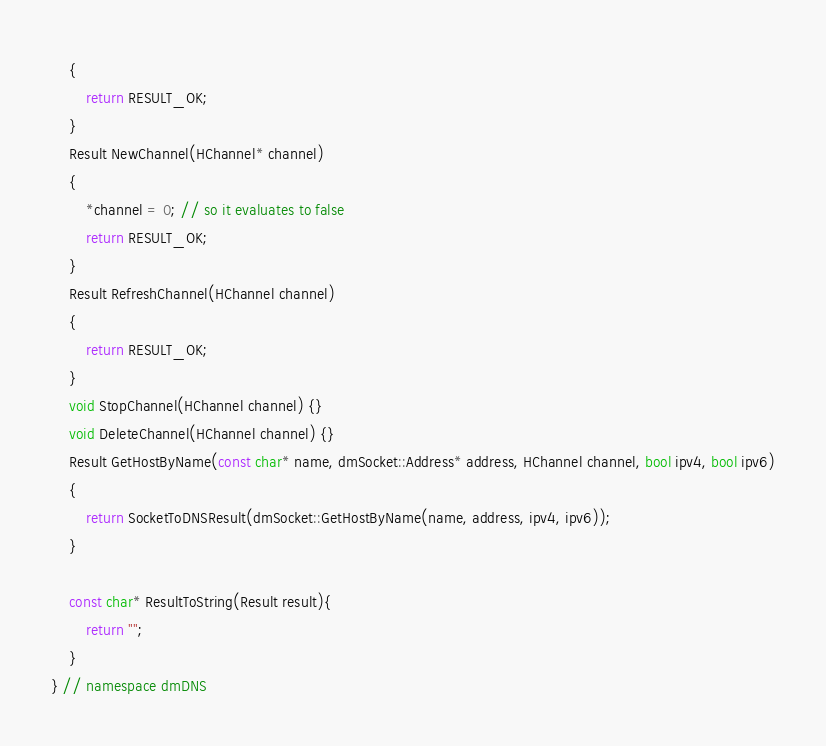<code> <loc_0><loc_0><loc_500><loc_500><_C++_>    {
        return RESULT_OK;
    }
    Result NewChannel(HChannel* channel)
    {
        *channel = 0; // so it evaluates to false
        return RESULT_OK;
    }
    Result RefreshChannel(HChannel channel)
    {
        return RESULT_OK;
    }
    void StopChannel(HChannel channel) {}
    void DeleteChannel(HChannel channel) {}
    Result GetHostByName(const char* name, dmSocket::Address* address, HChannel channel, bool ipv4, bool ipv6)
    {
        return SocketToDNSResult(dmSocket::GetHostByName(name, address, ipv4, ipv6));
    }

    const char* ResultToString(Result result){
        return "";
    }
} // namespace dmDNS
</code> 